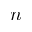<formula> <loc_0><loc_0><loc_500><loc_500>n</formula> 